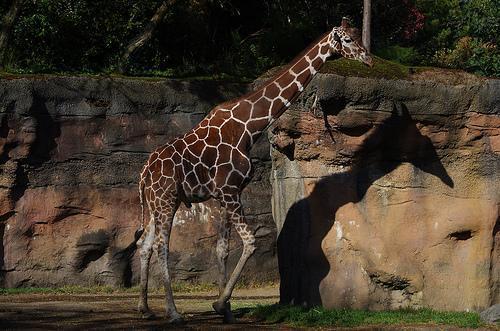How many giraffes are in the picture?
Give a very brief answer. 1. How many people are in the picture?
Give a very brief answer. 0. 